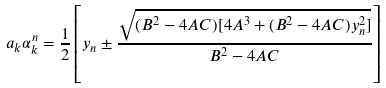<formula> <loc_0><loc_0><loc_500><loc_500>a _ { k } \alpha _ { k } ^ { n } = \frac { 1 } { 2 } \left [ y _ { n } \pm \frac { \sqrt { ( B ^ { 2 } - 4 A C ) [ 4 A ^ { 3 } + ( B ^ { 2 } - 4 A C ) y _ { n } ^ { 2 } ] } } { B ^ { 2 } - 4 A C } \right ]</formula> 